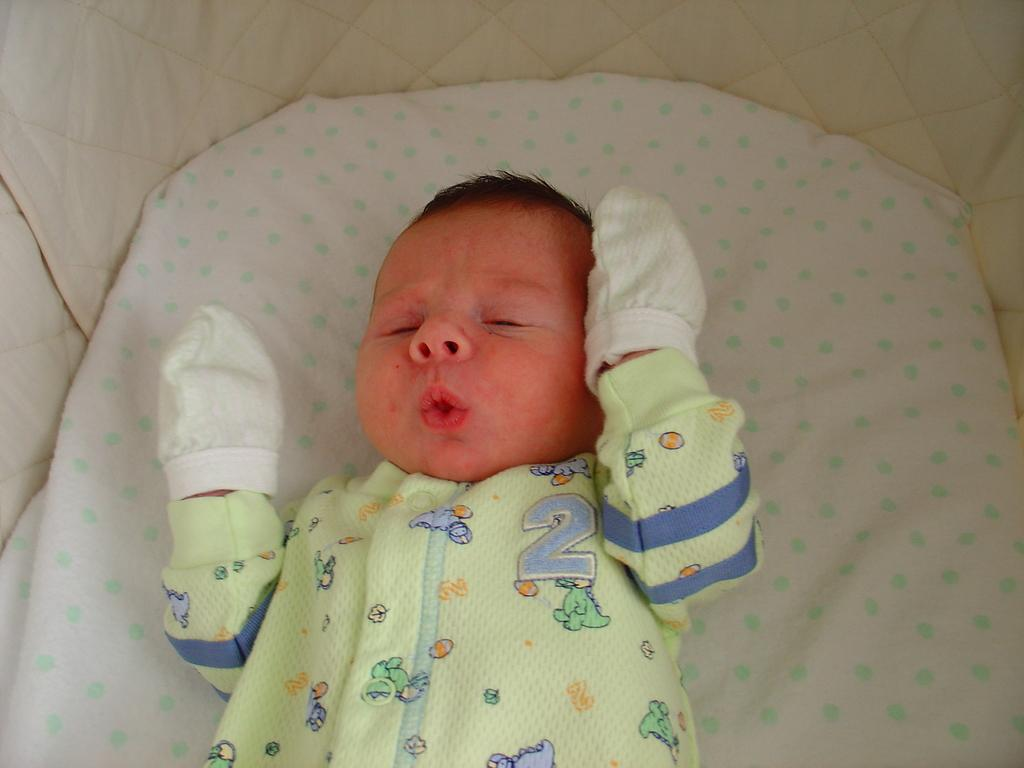What is the main subject of the picture? The main subject of the picture is a baby. Where is the baby located in the image? The baby is lying on a bed. What is the baby wearing in the picture? The baby is wearing gloves. What type of copper sheet is visible in the image? There is no copper sheet present in the image. What is the size of the baby in the image? The size of the baby cannot be determined from the image alone, as it depends on the perspective and distance from the camera. 